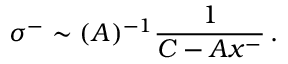Convert formula to latex. <formula><loc_0><loc_0><loc_500><loc_500>\sigma ^ { - } \sim ( A ) ^ { - 1 } \frac { 1 } { C - A x ^ { - } } \, .</formula> 